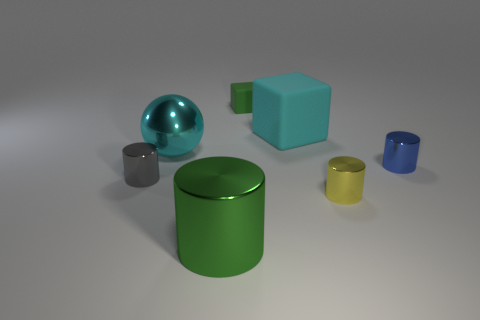Can you describe the lighting in the scene? The lighting appears to be soft and diffused, coming from above. It creates gentle shadows on the ground, indicating an indirect light source without harsh direct illumination. 